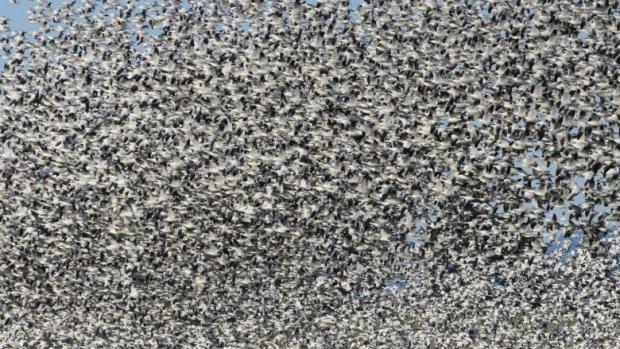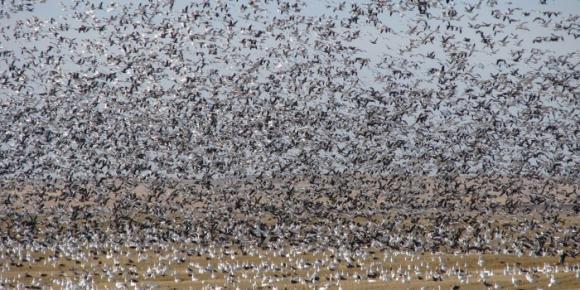The first image is the image on the left, the second image is the image on the right. Examine the images to the left and right. Is the description "A body of water is visible below a sky full of birds in at least one image." accurate? Answer yes or no. No. The first image is the image on the left, the second image is the image on the right. Examine the images to the left and right. Is the description "A very large flock of birds is seen flying over water in at least one of the images." accurate? Answer yes or no. No. 